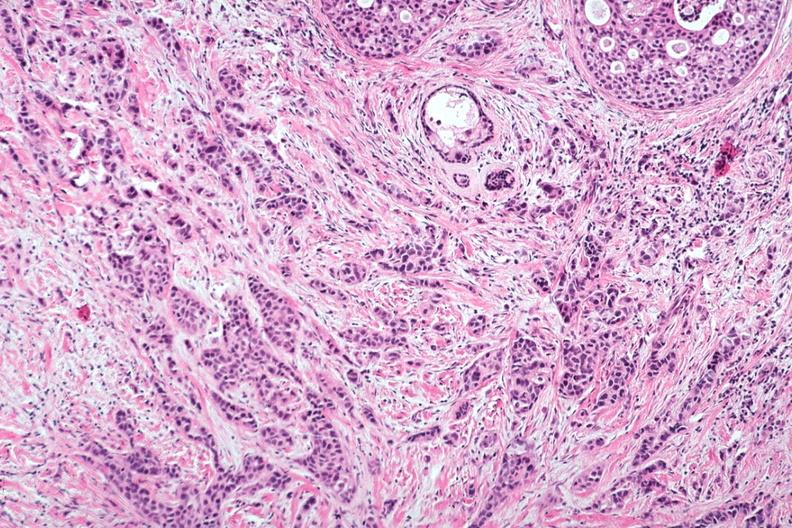s breast present?
Answer the question using a single word or phrase. Yes 